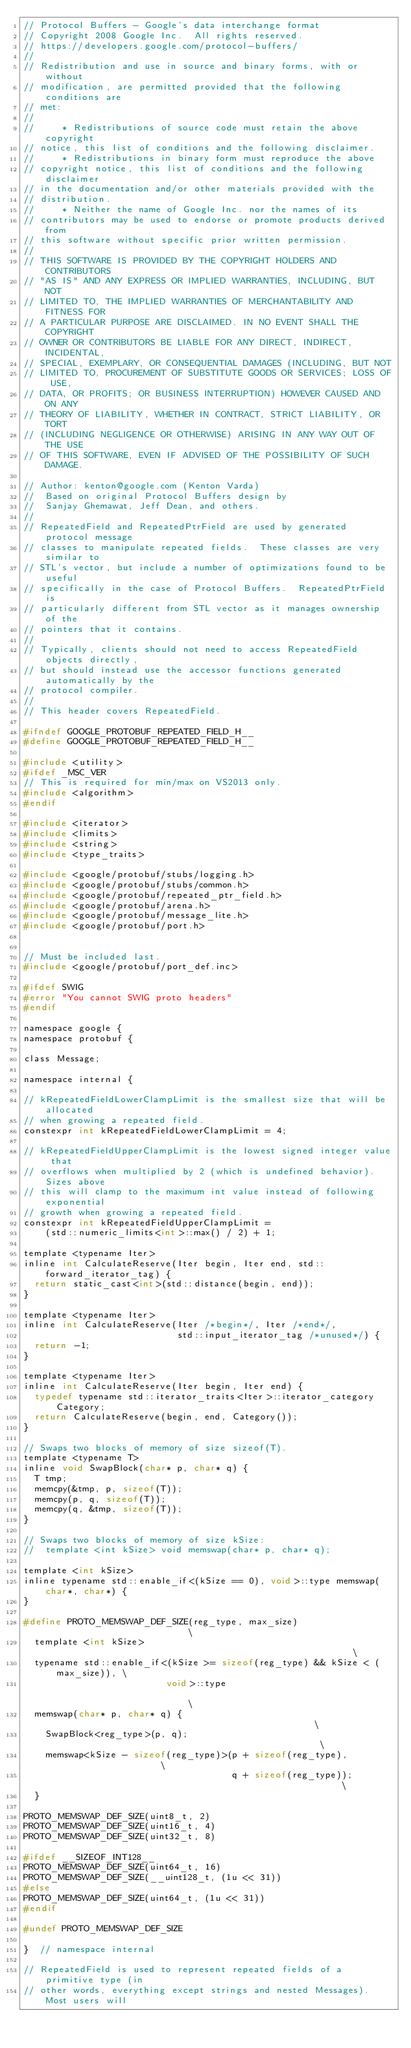Convert code to text. <code><loc_0><loc_0><loc_500><loc_500><_C_>// Protocol Buffers - Google's data interchange format
// Copyright 2008 Google Inc.  All rights reserved.
// https://developers.google.com/protocol-buffers/
//
// Redistribution and use in source and binary forms, with or without
// modification, are permitted provided that the following conditions are
// met:
//
//     * Redistributions of source code must retain the above copyright
// notice, this list of conditions and the following disclaimer.
//     * Redistributions in binary form must reproduce the above
// copyright notice, this list of conditions and the following disclaimer
// in the documentation and/or other materials provided with the
// distribution.
//     * Neither the name of Google Inc. nor the names of its
// contributors may be used to endorse or promote products derived from
// this software without specific prior written permission.
//
// THIS SOFTWARE IS PROVIDED BY THE COPYRIGHT HOLDERS AND CONTRIBUTORS
// "AS IS" AND ANY EXPRESS OR IMPLIED WARRANTIES, INCLUDING, BUT NOT
// LIMITED TO, THE IMPLIED WARRANTIES OF MERCHANTABILITY AND FITNESS FOR
// A PARTICULAR PURPOSE ARE DISCLAIMED. IN NO EVENT SHALL THE COPYRIGHT
// OWNER OR CONTRIBUTORS BE LIABLE FOR ANY DIRECT, INDIRECT, INCIDENTAL,
// SPECIAL, EXEMPLARY, OR CONSEQUENTIAL DAMAGES (INCLUDING, BUT NOT
// LIMITED TO, PROCUREMENT OF SUBSTITUTE GOODS OR SERVICES; LOSS OF USE,
// DATA, OR PROFITS; OR BUSINESS INTERRUPTION) HOWEVER CAUSED AND ON ANY
// THEORY OF LIABILITY, WHETHER IN CONTRACT, STRICT LIABILITY, OR TORT
// (INCLUDING NEGLIGENCE OR OTHERWISE) ARISING IN ANY WAY OUT OF THE USE
// OF THIS SOFTWARE, EVEN IF ADVISED OF THE POSSIBILITY OF SUCH DAMAGE.

// Author: kenton@google.com (Kenton Varda)
//  Based on original Protocol Buffers design by
//  Sanjay Ghemawat, Jeff Dean, and others.
//
// RepeatedField and RepeatedPtrField are used by generated protocol message
// classes to manipulate repeated fields.  These classes are very similar to
// STL's vector, but include a number of optimizations found to be useful
// specifically in the case of Protocol Buffers.  RepeatedPtrField is
// particularly different from STL vector as it manages ownership of the
// pointers that it contains.
//
// Typically, clients should not need to access RepeatedField objects directly,
// but should instead use the accessor functions generated automatically by the
// protocol compiler.
//
// This header covers RepeatedField.

#ifndef GOOGLE_PROTOBUF_REPEATED_FIELD_H__
#define GOOGLE_PROTOBUF_REPEATED_FIELD_H__

#include <utility>
#ifdef _MSC_VER
// This is required for min/max on VS2013 only.
#include <algorithm>
#endif

#include <iterator>
#include <limits>
#include <string>
#include <type_traits>

#include <google/protobuf/stubs/logging.h>
#include <google/protobuf/stubs/common.h>
#include <google/protobuf/repeated_ptr_field.h>
#include <google/protobuf/arena.h>
#include <google/protobuf/message_lite.h>
#include <google/protobuf/port.h>


// Must be included last.
#include <google/protobuf/port_def.inc>

#ifdef SWIG
#error "You cannot SWIG proto headers"
#endif

namespace google {
namespace protobuf {

class Message;

namespace internal {

// kRepeatedFieldLowerClampLimit is the smallest size that will be allocated
// when growing a repeated field.
constexpr int kRepeatedFieldLowerClampLimit = 4;

// kRepeatedFieldUpperClampLimit is the lowest signed integer value that
// overflows when multiplied by 2 (which is undefined behavior). Sizes above
// this will clamp to the maximum int value instead of following exponential
// growth when growing a repeated field.
constexpr int kRepeatedFieldUpperClampLimit =
    (std::numeric_limits<int>::max() / 2) + 1;

template <typename Iter>
inline int CalculateReserve(Iter begin, Iter end, std::forward_iterator_tag) {
  return static_cast<int>(std::distance(begin, end));
}

template <typename Iter>
inline int CalculateReserve(Iter /*begin*/, Iter /*end*/,
                            std::input_iterator_tag /*unused*/) {
  return -1;
}

template <typename Iter>
inline int CalculateReserve(Iter begin, Iter end) {
  typedef typename std::iterator_traits<Iter>::iterator_category Category;
  return CalculateReserve(begin, end, Category());
}

// Swaps two blocks of memory of size sizeof(T).
template <typename T>
inline void SwapBlock(char* p, char* q) {
  T tmp;
  memcpy(&tmp, p, sizeof(T));
  memcpy(p, q, sizeof(T));
  memcpy(q, &tmp, sizeof(T));
}

// Swaps two blocks of memory of size kSize:
//  template <int kSize> void memswap(char* p, char* q);

template <int kSize>
inline typename std::enable_if<(kSize == 0), void>::type memswap(char*, char*) {
}

#define PROTO_MEMSWAP_DEF_SIZE(reg_type, max_size)                           \
  template <int kSize>                                                       \
  typename std::enable_if<(kSize >= sizeof(reg_type) && kSize < (max_size)), \
                          void>::type                                        \
  memswap(char* p, char* q) {                                                \
    SwapBlock<reg_type>(p, q);                                               \
    memswap<kSize - sizeof(reg_type)>(p + sizeof(reg_type),                  \
                                      q + sizeof(reg_type));                 \
  }

PROTO_MEMSWAP_DEF_SIZE(uint8_t, 2)
PROTO_MEMSWAP_DEF_SIZE(uint16_t, 4)
PROTO_MEMSWAP_DEF_SIZE(uint32_t, 8)

#ifdef __SIZEOF_INT128__
PROTO_MEMSWAP_DEF_SIZE(uint64_t, 16)
PROTO_MEMSWAP_DEF_SIZE(__uint128_t, (1u << 31))
#else
PROTO_MEMSWAP_DEF_SIZE(uint64_t, (1u << 31))
#endif

#undef PROTO_MEMSWAP_DEF_SIZE

}  // namespace internal

// RepeatedField is used to represent repeated fields of a primitive type (in
// other words, everything except strings and nested Messages).  Most users will</code> 